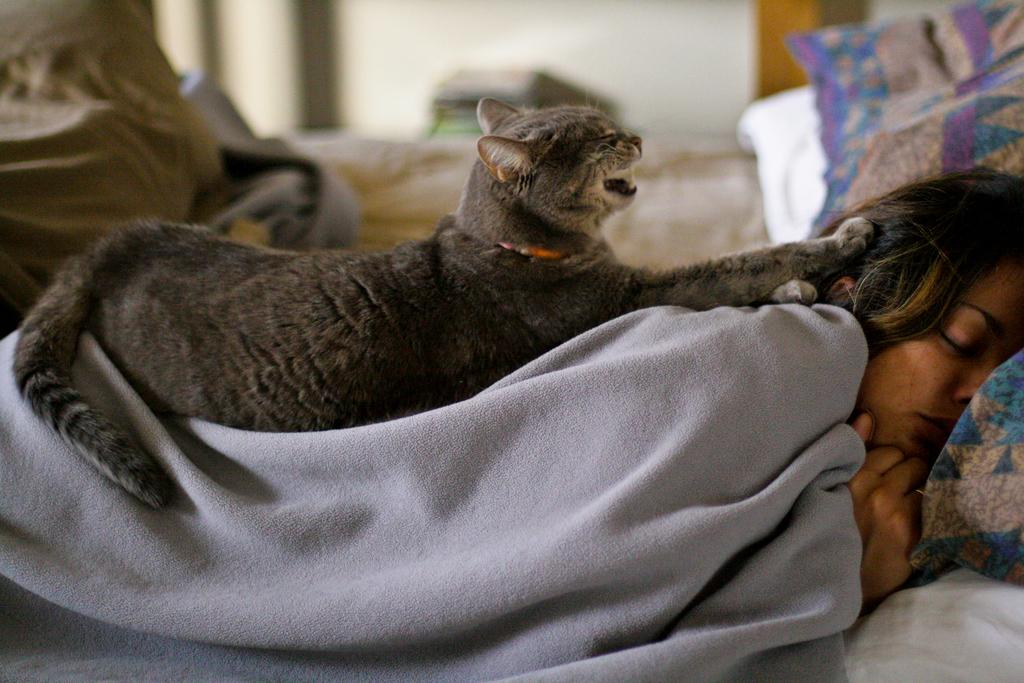Who is the main subject in the image? There is a girl in the image. What is the girl doing in the image? The girl is sleeping on a bed. How is the girl covered in the image? The girl is covered by a blanket. What other living creature is present in the image? There is a cat in the image. Where is the cat located in relation to the girl? The cat is sitting on the blanket. What type of insurance policy does the girl have for the cat in the image? There is no information about insurance policies in the image, and the presence of a cat does not imply any insurance coverage. 